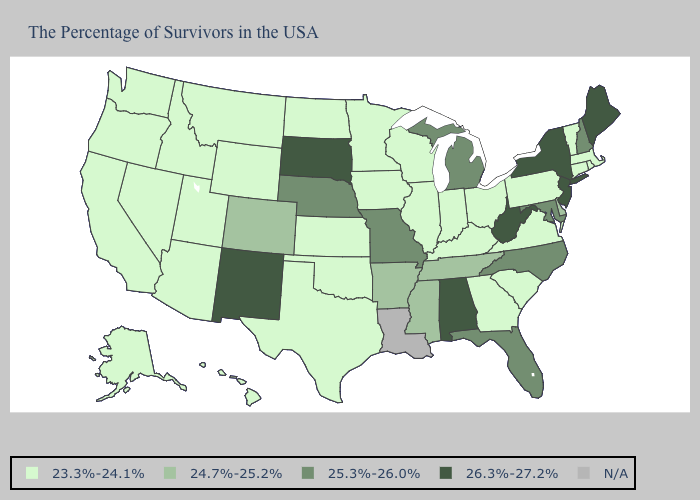Among the states that border Delaware , which have the lowest value?
Be succinct. Pennsylvania. What is the lowest value in the Northeast?
Answer briefly. 23.3%-24.1%. Which states hav the highest value in the MidWest?
Answer briefly. South Dakota. Which states have the lowest value in the MidWest?
Concise answer only. Ohio, Indiana, Wisconsin, Illinois, Minnesota, Iowa, Kansas, North Dakota. Name the states that have a value in the range 23.3%-24.1%?
Keep it brief. Massachusetts, Rhode Island, Vermont, Connecticut, Pennsylvania, Virginia, South Carolina, Ohio, Georgia, Kentucky, Indiana, Wisconsin, Illinois, Minnesota, Iowa, Kansas, Oklahoma, Texas, North Dakota, Wyoming, Utah, Montana, Arizona, Idaho, Nevada, California, Washington, Oregon, Alaska, Hawaii. Which states have the lowest value in the MidWest?
Keep it brief. Ohio, Indiana, Wisconsin, Illinois, Minnesota, Iowa, Kansas, North Dakota. What is the lowest value in the USA?
Keep it brief. 23.3%-24.1%. Among the states that border South Carolina , does Georgia have the lowest value?
Short answer required. Yes. Which states have the highest value in the USA?
Keep it brief. Maine, New York, New Jersey, West Virginia, Alabama, South Dakota, New Mexico. Name the states that have a value in the range 23.3%-24.1%?
Answer briefly. Massachusetts, Rhode Island, Vermont, Connecticut, Pennsylvania, Virginia, South Carolina, Ohio, Georgia, Kentucky, Indiana, Wisconsin, Illinois, Minnesota, Iowa, Kansas, Oklahoma, Texas, North Dakota, Wyoming, Utah, Montana, Arizona, Idaho, Nevada, California, Washington, Oregon, Alaska, Hawaii. What is the value of North Dakota?
Quick response, please. 23.3%-24.1%. Which states have the lowest value in the MidWest?
Give a very brief answer. Ohio, Indiana, Wisconsin, Illinois, Minnesota, Iowa, Kansas, North Dakota. Among the states that border Washington , which have the lowest value?
Keep it brief. Idaho, Oregon. Does Kentucky have the highest value in the South?
Answer briefly. No. 